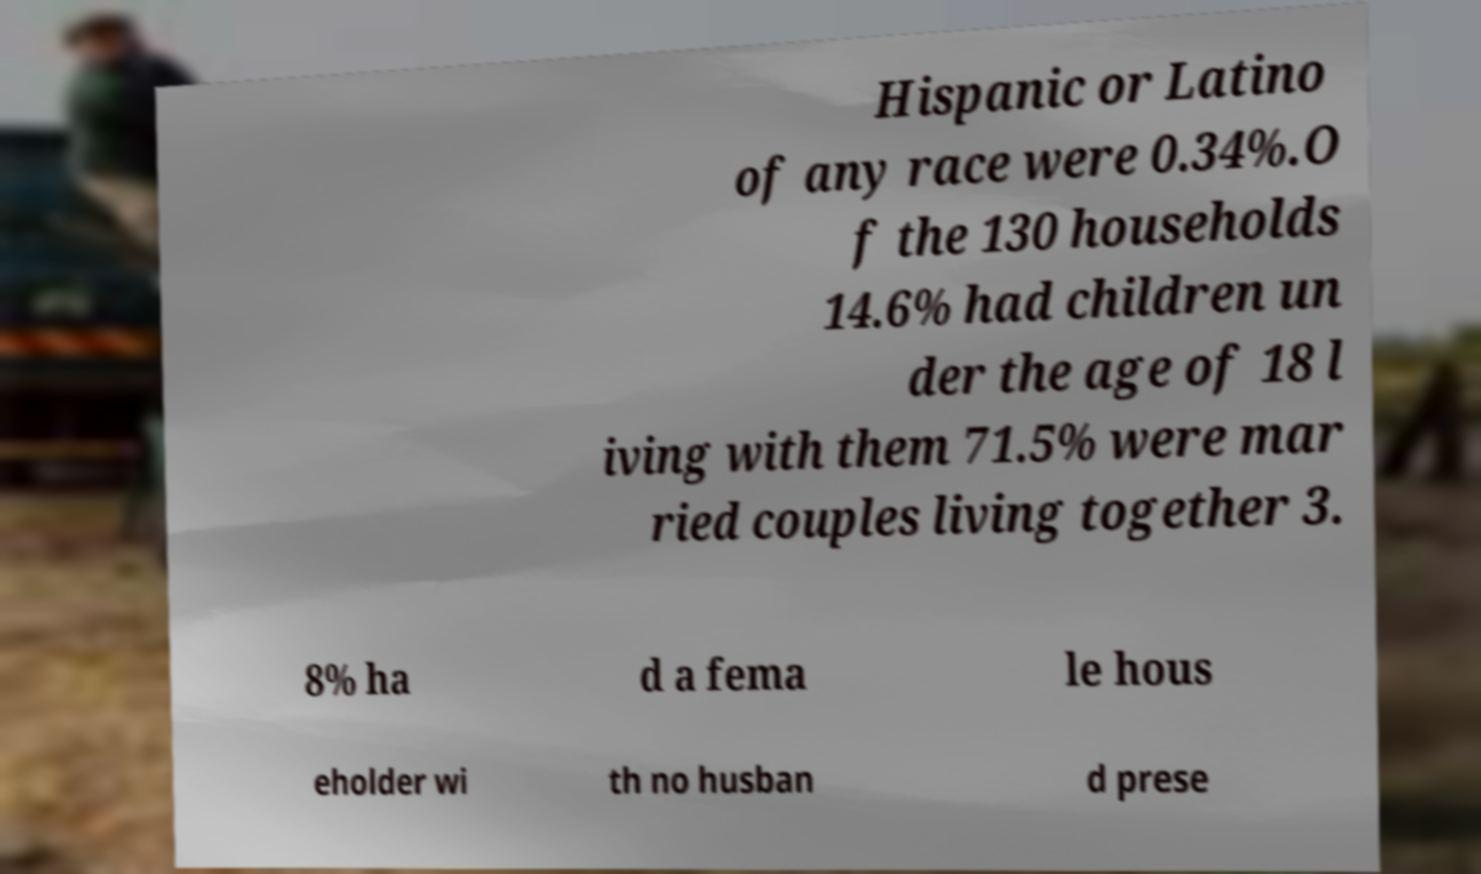Can you accurately transcribe the text from the provided image for me? Hispanic or Latino of any race were 0.34%.O f the 130 households 14.6% had children un der the age of 18 l iving with them 71.5% were mar ried couples living together 3. 8% ha d a fema le hous eholder wi th no husban d prese 